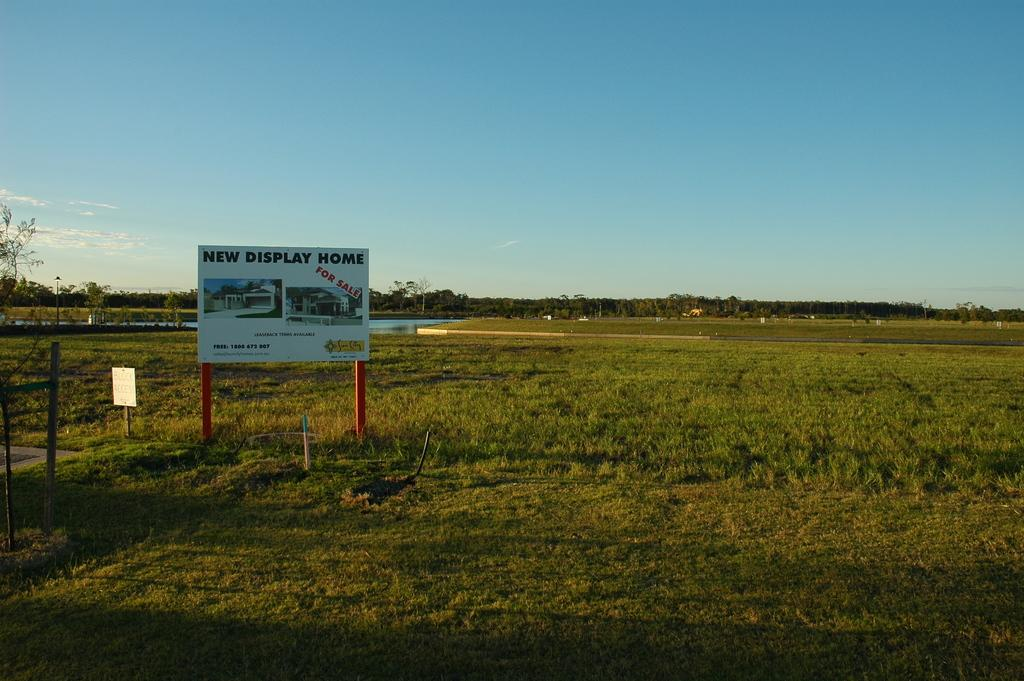What type of surface is on the ground in the image? There is grass on the ground in the image. What structures can be seen in the image? There are poles and a board on the ground in the image. What can be seen in the background of the image? There are trees, water, houses, and clouds in the sky in the background of the image. What type of store can be seen in the image? There is no store present in the image. What meal is being prepared on the board in the image? There is no meal being prepared on the board in the image; it is just a board on the ground. 